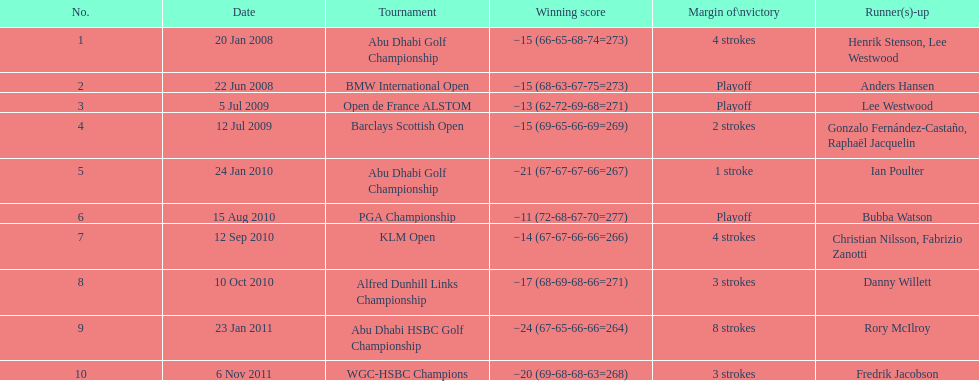How many triumphing scores fell under -14? 2. 